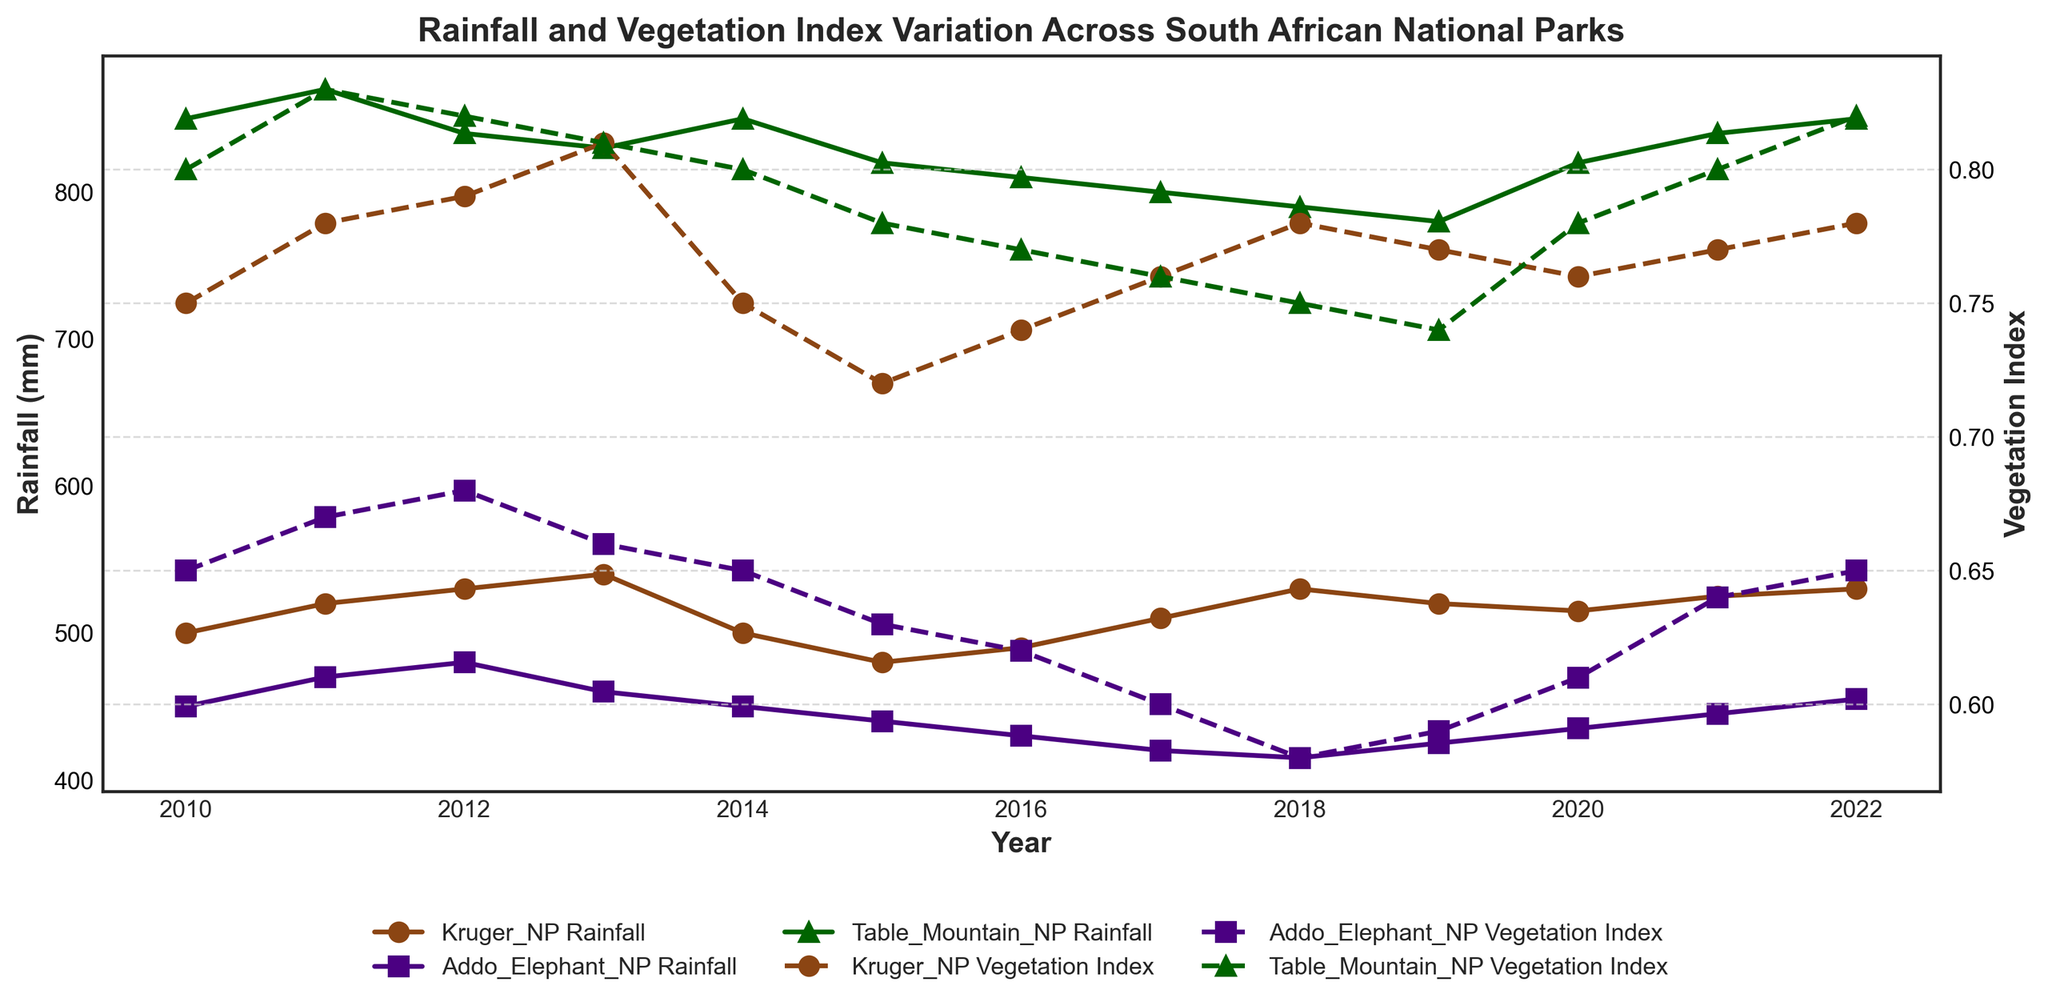What is the title of the figure? The title of any figure is generally placed at the top, and it offers a brief description of the visual information presented. In this case, the title is "Rainfall and Vegetation Index Variation Across South African National Parks".
Answer: Rainfall and Vegetation Index Variation Across South African National Parks How many national parks are represented in the figure? By examining the legend and the different color lines and markers used in the figure, we can see that there are three national parks: Kruger NP, Addo Elephant NP, and Table Mountain NP.
Answer: Three Which national park had the highest rainfall in 2022? To find the highest rainfall for 2022, we need to look at the endpoints of the rainfall lines for each park in the year 2022 on the x-axis. Table Mountain NP shows the highest endpoint.
Answer: Table Mountain NP What is the trend of the vegetation index for Kruger NP from 2010 to 2022? By following the Kruger NP's dashed line on the right y-axis (vegetation index) from the year 2010 to 2022, we see a fluctuating but overall slightly increasing trend.
Answer: Slightly increasing Which year had the lowest rainfall for Addo Elephant NP? To find the lowest rainfall for Addo Elephant NP, we need to visually scan the line representing Addo Elephant NP's rainfall across the years. The year 2018 shows the lowest point.
Answer: 2018 What is the average rainfall for Table Mountain NP over the entire period? We need to sum the rainfall values for Table Mountain NP from 2010 to 2022 and then divide by the number of years (13). (850+870+840+830+850+820+810+800+790+780+820+840+850)/13 = ~826.15
Answer: ~826.15 mm By how much did the vegetation index for Addo Elephant NP change from 2015 to 2018? By observing the vegetation index line for Addo Elephant NP, we find the values for 2015 and 2018, which are 0.63 and 0.58, respectively. The change is 0.63 - 0.58 = 0.05.
Answer: 0.05 Which national park shows a decreasing trend in both rainfall and vegetation index from 2010 to 2015? We have to trace the lines for both the rainfall and vegetation index for each park from 2010 to 2015. Kruger NP shows a decreasing trend in both rainfall and vegetation index during this period.
Answer: Kruger NP Compare the vegetation index for Table Mountain NP in 2010 and 2022. How much did it change? We need to check the values for the vegetation index for Table Mountain NP in 2010 and 2022, which are 0.80 and 0.82, respectively. The change is 0.82 - 0.80 = 0.02.
Answer: 0.02 In which year(s) did Kruger NP and Addo Elephant NP have the same rainfall? We need to identify the years when the Kruger NP and Addo Elephant NP rainfall lines intersect or are at the same level. The year 2014 shows the same rainfall for both parks (450 mm).
Answer: 2014 